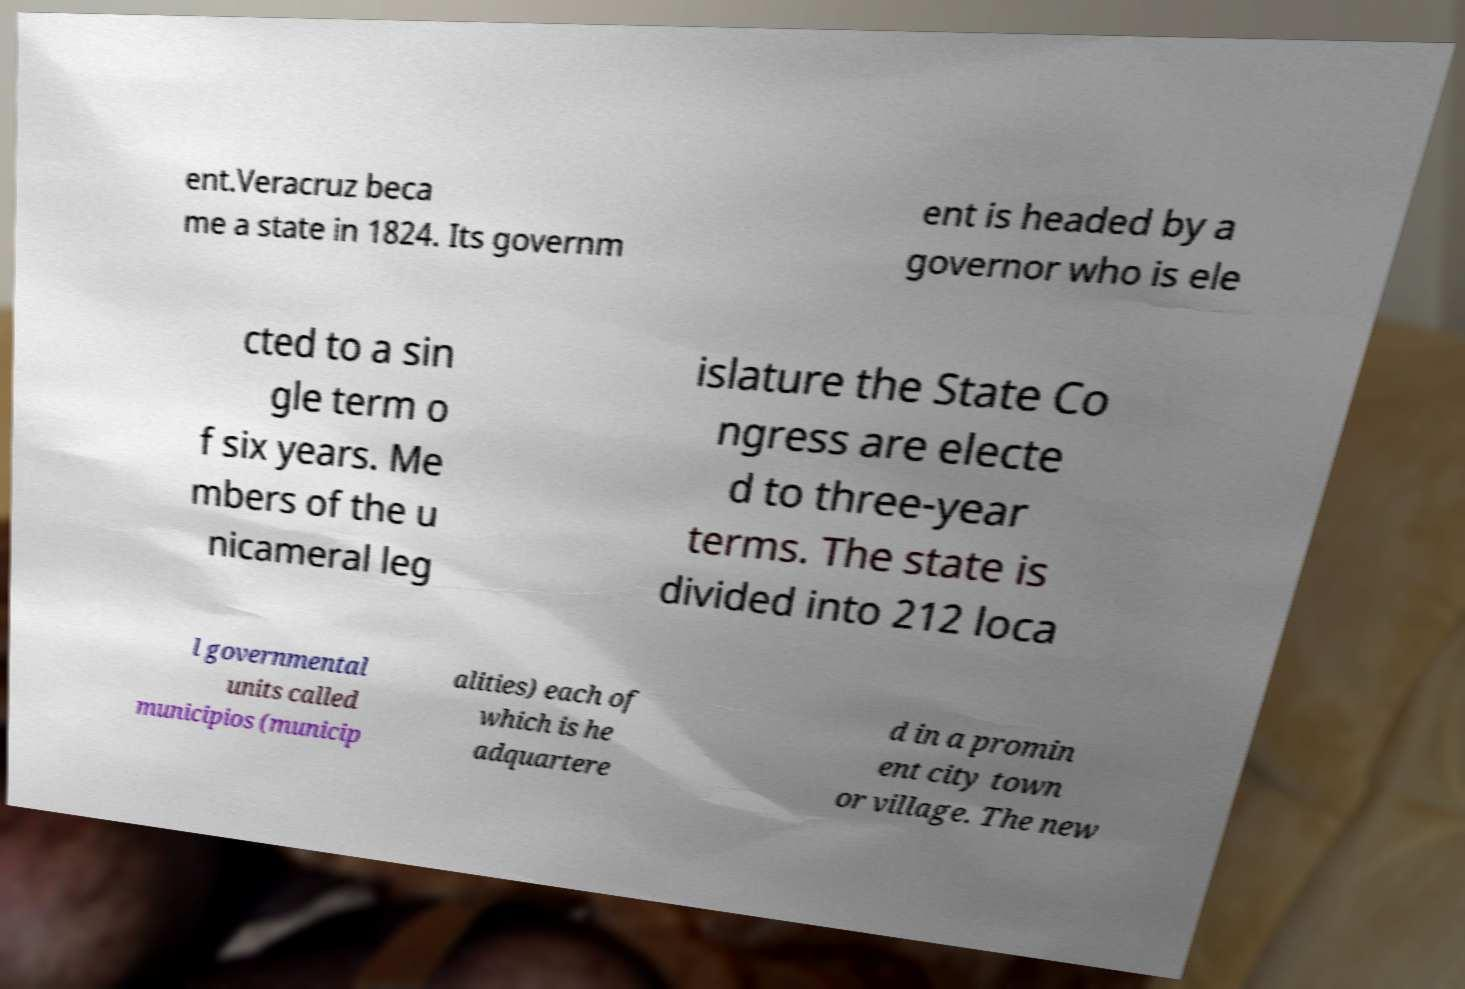What messages or text are displayed in this image? I need them in a readable, typed format. ent.Veracruz beca me a state in 1824. Its governm ent is headed by a governor who is ele cted to a sin gle term o f six years. Me mbers of the u nicameral leg islature the State Co ngress are electe d to three-year terms. The state is divided into 212 loca l governmental units called municipios (municip alities) each of which is he adquartere d in a promin ent city town or village. The new 